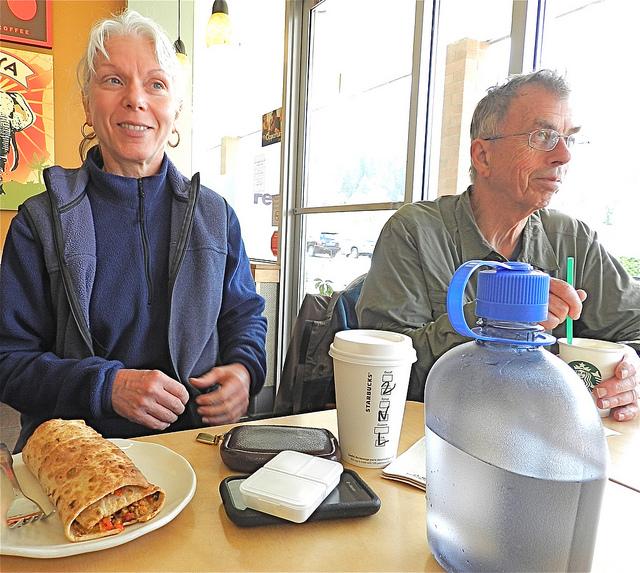What is in the clear container with the blue top?
Write a very short answer. Water. What is the white container on top of the cell phone?
Write a very short answer. Pill box. What store sold that coffee?
Give a very brief answer. Starbucks. Is the man happy?
Give a very brief answer. Yes. Is the man wearing a colorful shirt?
Short answer required. No. What is the business called that this picture was taken in?
Write a very short answer. Starbucks. 